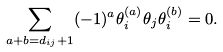Convert formula to latex. <formula><loc_0><loc_0><loc_500><loc_500>\sum _ { a + b = d _ { i j } + 1 } ( - 1 ) ^ { a } \theta _ { i } ^ { ( a ) } \theta _ { j } \theta _ { i } ^ { ( b ) } = 0 .</formula> 